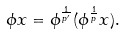Convert formula to latex. <formula><loc_0><loc_0><loc_500><loc_500>\phi x = \phi ^ { \frac { 1 } { p ^ { \prime } } } ( \phi ^ { \frac { 1 } { p } } x ) .</formula> 